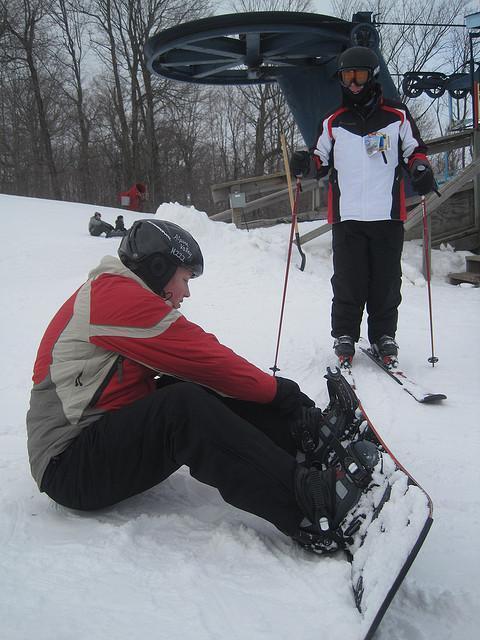How many people are there?
Give a very brief answer. 2. 